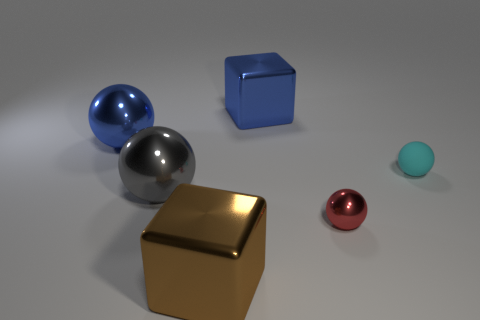What number of tiny red cylinders are there?
Your response must be concise. 0. What shape is the tiny object that is made of the same material as the large gray object?
Your response must be concise. Sphere. There is a big metallic object that is right of the brown block; does it have the same color as the shiny ball that is behind the cyan object?
Your answer should be very brief. Yes. Are there an equal number of tiny balls that are on the right side of the tiny red sphere and small blue matte spheres?
Your answer should be very brief. No. There is a blue cube; what number of balls are to the left of it?
Offer a terse response. 2. What is the size of the brown metal cube?
Provide a succinct answer. Large. The small thing that is made of the same material as the large brown block is what color?
Provide a succinct answer. Red. How many gray metal things have the same size as the blue metal ball?
Your answer should be very brief. 1. Do the large blue thing that is left of the large brown metal object and the red thing have the same material?
Provide a short and direct response. Yes. Is the number of large spheres that are to the right of the large brown object less than the number of brown cubes?
Provide a succinct answer. Yes. 